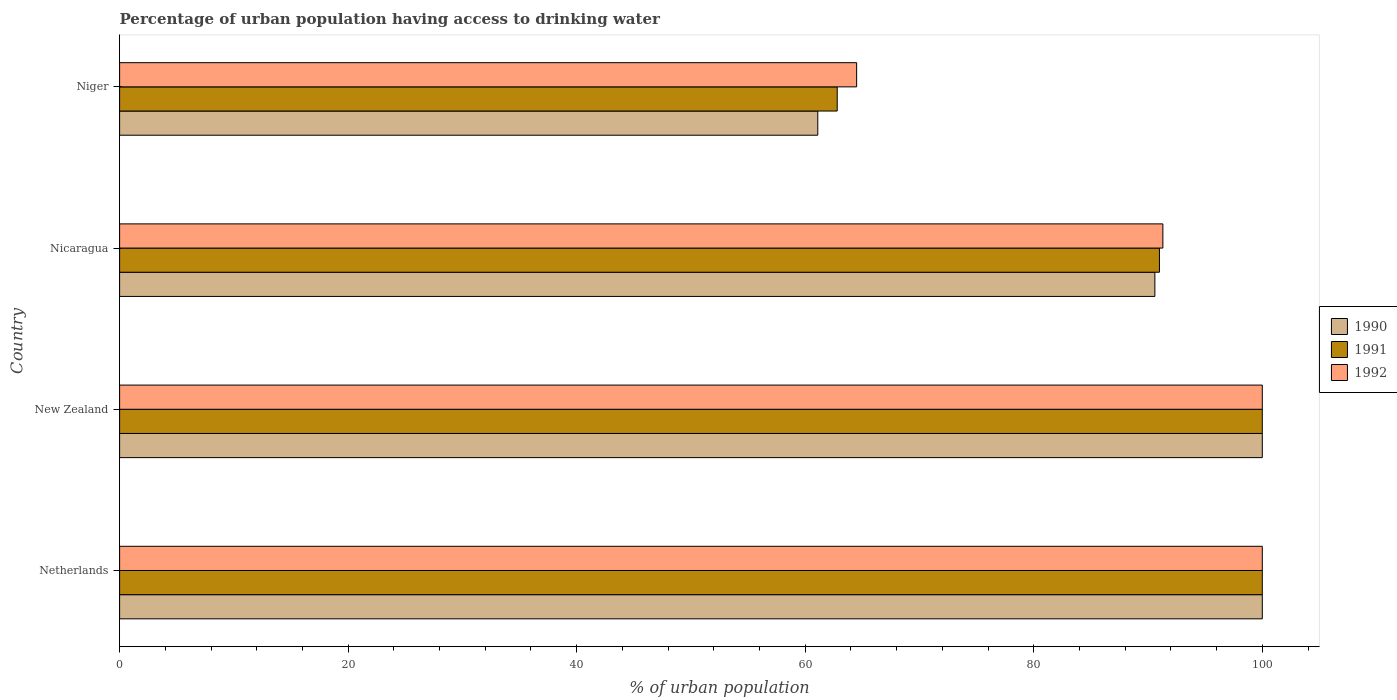How many different coloured bars are there?
Provide a succinct answer. 3. Are the number of bars per tick equal to the number of legend labels?
Offer a very short reply. Yes. How many bars are there on the 2nd tick from the top?
Offer a terse response. 3. What is the label of the 3rd group of bars from the top?
Your answer should be very brief. New Zealand. What is the percentage of urban population having access to drinking water in 1990 in Niger?
Ensure brevity in your answer.  61.1. Across all countries, what is the minimum percentage of urban population having access to drinking water in 1991?
Give a very brief answer. 62.8. In which country was the percentage of urban population having access to drinking water in 1990 maximum?
Offer a very short reply. Netherlands. In which country was the percentage of urban population having access to drinking water in 1990 minimum?
Make the answer very short. Niger. What is the total percentage of urban population having access to drinking water in 1991 in the graph?
Make the answer very short. 353.8. What is the difference between the percentage of urban population having access to drinking water in 1990 in New Zealand and that in Niger?
Make the answer very short. 38.9. What is the difference between the percentage of urban population having access to drinking water in 1991 in New Zealand and the percentage of urban population having access to drinking water in 1990 in Netherlands?
Provide a short and direct response. 0. What is the average percentage of urban population having access to drinking water in 1990 per country?
Provide a succinct answer. 87.93. What is the difference between the percentage of urban population having access to drinking water in 1992 and percentage of urban population having access to drinking water in 1990 in Niger?
Make the answer very short. 3.4. In how many countries, is the percentage of urban population having access to drinking water in 1992 greater than 32 %?
Offer a very short reply. 4. What is the ratio of the percentage of urban population having access to drinking water in 1992 in Netherlands to that in Niger?
Make the answer very short. 1.55. Is the percentage of urban population having access to drinking water in 1990 in Netherlands less than that in Nicaragua?
Offer a very short reply. No. Is the difference between the percentage of urban population having access to drinking water in 1992 in New Zealand and Nicaragua greater than the difference between the percentage of urban population having access to drinking water in 1990 in New Zealand and Nicaragua?
Offer a terse response. No. What is the difference between the highest and the second highest percentage of urban population having access to drinking water in 1991?
Offer a very short reply. 0. What is the difference between the highest and the lowest percentage of urban population having access to drinking water in 1990?
Your answer should be very brief. 38.9. What does the 1st bar from the top in Nicaragua represents?
Your answer should be compact. 1992. How many bars are there?
Provide a succinct answer. 12. How many countries are there in the graph?
Your response must be concise. 4. Are the values on the major ticks of X-axis written in scientific E-notation?
Provide a succinct answer. No. How are the legend labels stacked?
Make the answer very short. Vertical. What is the title of the graph?
Your answer should be very brief. Percentage of urban population having access to drinking water. What is the label or title of the X-axis?
Offer a very short reply. % of urban population. What is the label or title of the Y-axis?
Provide a succinct answer. Country. What is the % of urban population of 1991 in Netherlands?
Ensure brevity in your answer.  100. What is the % of urban population of 1992 in Netherlands?
Give a very brief answer. 100. What is the % of urban population of 1990 in New Zealand?
Make the answer very short. 100. What is the % of urban population of 1991 in New Zealand?
Offer a very short reply. 100. What is the % of urban population in 1992 in New Zealand?
Provide a short and direct response. 100. What is the % of urban population of 1990 in Nicaragua?
Your response must be concise. 90.6. What is the % of urban population in 1991 in Nicaragua?
Give a very brief answer. 91. What is the % of urban population of 1992 in Nicaragua?
Offer a very short reply. 91.3. What is the % of urban population in 1990 in Niger?
Give a very brief answer. 61.1. What is the % of urban population of 1991 in Niger?
Your answer should be compact. 62.8. What is the % of urban population in 1992 in Niger?
Your answer should be very brief. 64.5. Across all countries, what is the maximum % of urban population of 1992?
Provide a succinct answer. 100. Across all countries, what is the minimum % of urban population in 1990?
Offer a terse response. 61.1. Across all countries, what is the minimum % of urban population of 1991?
Your response must be concise. 62.8. Across all countries, what is the minimum % of urban population of 1992?
Your answer should be compact. 64.5. What is the total % of urban population in 1990 in the graph?
Your response must be concise. 351.7. What is the total % of urban population of 1991 in the graph?
Provide a succinct answer. 353.8. What is the total % of urban population in 1992 in the graph?
Your answer should be very brief. 355.8. What is the difference between the % of urban population in 1990 in Netherlands and that in Nicaragua?
Offer a terse response. 9.4. What is the difference between the % of urban population in 1991 in Netherlands and that in Nicaragua?
Provide a short and direct response. 9. What is the difference between the % of urban population in 1990 in Netherlands and that in Niger?
Offer a very short reply. 38.9. What is the difference between the % of urban population of 1991 in Netherlands and that in Niger?
Your answer should be very brief. 37.2. What is the difference between the % of urban population in 1992 in Netherlands and that in Niger?
Your response must be concise. 35.5. What is the difference between the % of urban population in 1990 in New Zealand and that in Nicaragua?
Give a very brief answer. 9.4. What is the difference between the % of urban population in 1991 in New Zealand and that in Nicaragua?
Provide a short and direct response. 9. What is the difference between the % of urban population in 1992 in New Zealand and that in Nicaragua?
Your response must be concise. 8.7. What is the difference between the % of urban population in 1990 in New Zealand and that in Niger?
Offer a very short reply. 38.9. What is the difference between the % of urban population in 1991 in New Zealand and that in Niger?
Offer a very short reply. 37.2. What is the difference between the % of urban population of 1992 in New Zealand and that in Niger?
Offer a terse response. 35.5. What is the difference between the % of urban population in 1990 in Nicaragua and that in Niger?
Make the answer very short. 29.5. What is the difference between the % of urban population of 1991 in Nicaragua and that in Niger?
Your response must be concise. 28.2. What is the difference between the % of urban population in 1992 in Nicaragua and that in Niger?
Offer a terse response. 26.8. What is the difference between the % of urban population in 1990 in Netherlands and the % of urban population in 1991 in Nicaragua?
Offer a terse response. 9. What is the difference between the % of urban population in 1991 in Netherlands and the % of urban population in 1992 in Nicaragua?
Make the answer very short. 8.7. What is the difference between the % of urban population in 1990 in Netherlands and the % of urban population in 1991 in Niger?
Keep it short and to the point. 37.2. What is the difference between the % of urban population in 1990 in Netherlands and the % of urban population in 1992 in Niger?
Keep it short and to the point. 35.5. What is the difference between the % of urban population of 1991 in Netherlands and the % of urban population of 1992 in Niger?
Give a very brief answer. 35.5. What is the difference between the % of urban population of 1990 in New Zealand and the % of urban population of 1992 in Nicaragua?
Your answer should be compact. 8.7. What is the difference between the % of urban population of 1991 in New Zealand and the % of urban population of 1992 in Nicaragua?
Your answer should be compact. 8.7. What is the difference between the % of urban population of 1990 in New Zealand and the % of urban population of 1991 in Niger?
Provide a short and direct response. 37.2. What is the difference between the % of urban population in 1990 in New Zealand and the % of urban population in 1992 in Niger?
Your response must be concise. 35.5. What is the difference between the % of urban population in 1991 in New Zealand and the % of urban population in 1992 in Niger?
Offer a very short reply. 35.5. What is the difference between the % of urban population in 1990 in Nicaragua and the % of urban population in 1991 in Niger?
Make the answer very short. 27.8. What is the difference between the % of urban population in 1990 in Nicaragua and the % of urban population in 1992 in Niger?
Make the answer very short. 26.1. What is the average % of urban population of 1990 per country?
Your answer should be compact. 87.92. What is the average % of urban population in 1991 per country?
Your response must be concise. 88.45. What is the average % of urban population in 1992 per country?
Give a very brief answer. 88.95. What is the difference between the % of urban population of 1990 and % of urban population of 1991 in Netherlands?
Provide a short and direct response. 0. What is the difference between the % of urban population in 1990 and % of urban population in 1991 in New Zealand?
Provide a short and direct response. 0. What is the difference between the % of urban population in 1990 and % of urban population in 1992 in New Zealand?
Your answer should be compact. 0. What is the difference between the % of urban population in 1991 and % of urban population in 1992 in New Zealand?
Provide a short and direct response. 0. What is the difference between the % of urban population in 1990 and % of urban population in 1991 in Nicaragua?
Your response must be concise. -0.4. What is the difference between the % of urban population of 1991 and % of urban population of 1992 in Nicaragua?
Make the answer very short. -0.3. What is the difference between the % of urban population in 1990 and % of urban population in 1991 in Niger?
Your response must be concise. -1.7. What is the difference between the % of urban population in 1991 and % of urban population in 1992 in Niger?
Give a very brief answer. -1.7. What is the ratio of the % of urban population of 1990 in Netherlands to that in Nicaragua?
Offer a very short reply. 1.1. What is the ratio of the % of urban population of 1991 in Netherlands to that in Nicaragua?
Your response must be concise. 1.1. What is the ratio of the % of urban population of 1992 in Netherlands to that in Nicaragua?
Your response must be concise. 1.1. What is the ratio of the % of urban population in 1990 in Netherlands to that in Niger?
Keep it short and to the point. 1.64. What is the ratio of the % of urban population in 1991 in Netherlands to that in Niger?
Your answer should be very brief. 1.59. What is the ratio of the % of urban population of 1992 in Netherlands to that in Niger?
Give a very brief answer. 1.55. What is the ratio of the % of urban population of 1990 in New Zealand to that in Nicaragua?
Provide a short and direct response. 1.1. What is the ratio of the % of urban population of 1991 in New Zealand to that in Nicaragua?
Ensure brevity in your answer.  1.1. What is the ratio of the % of urban population in 1992 in New Zealand to that in Nicaragua?
Provide a succinct answer. 1.1. What is the ratio of the % of urban population of 1990 in New Zealand to that in Niger?
Provide a succinct answer. 1.64. What is the ratio of the % of urban population in 1991 in New Zealand to that in Niger?
Ensure brevity in your answer.  1.59. What is the ratio of the % of urban population in 1992 in New Zealand to that in Niger?
Provide a succinct answer. 1.55. What is the ratio of the % of urban population of 1990 in Nicaragua to that in Niger?
Provide a succinct answer. 1.48. What is the ratio of the % of urban population of 1991 in Nicaragua to that in Niger?
Keep it short and to the point. 1.45. What is the ratio of the % of urban population in 1992 in Nicaragua to that in Niger?
Your response must be concise. 1.42. What is the difference between the highest and the lowest % of urban population of 1990?
Keep it short and to the point. 38.9. What is the difference between the highest and the lowest % of urban population of 1991?
Make the answer very short. 37.2. What is the difference between the highest and the lowest % of urban population of 1992?
Provide a short and direct response. 35.5. 